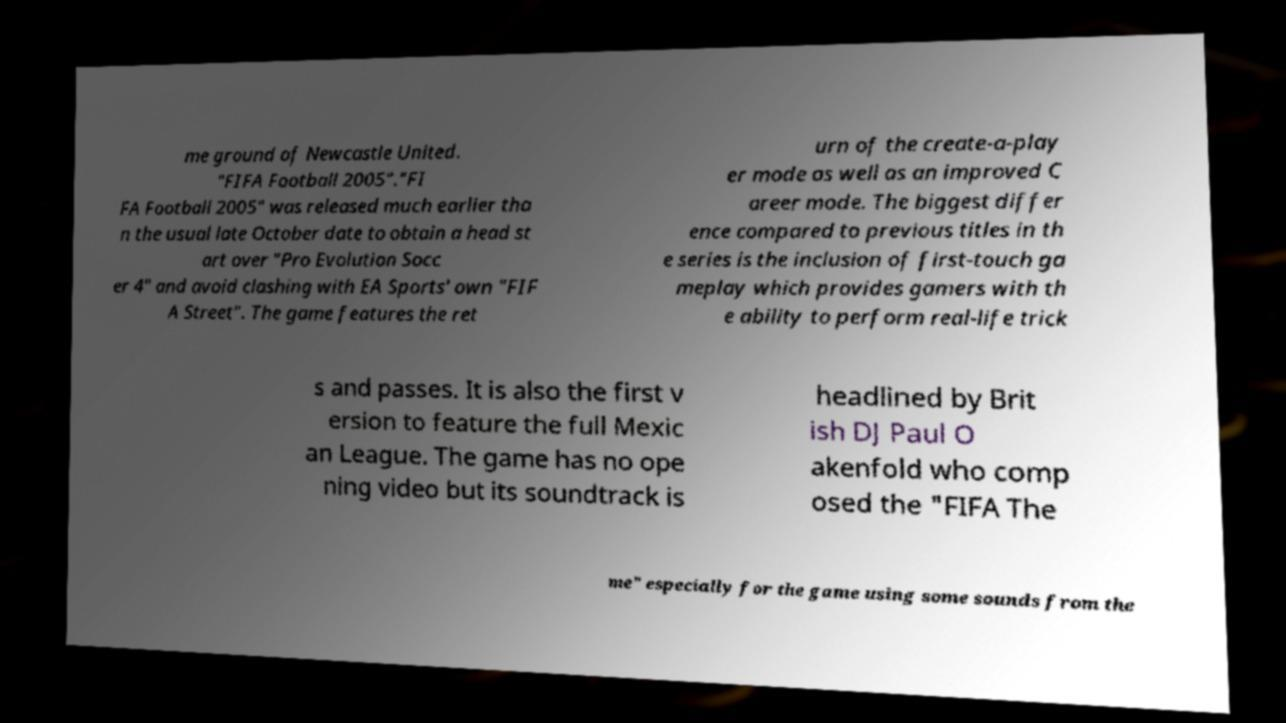Please read and relay the text visible in this image. What does it say? me ground of Newcastle United. "FIFA Football 2005"."FI FA Football 2005" was released much earlier tha n the usual late October date to obtain a head st art over "Pro Evolution Socc er 4" and avoid clashing with EA Sports' own "FIF A Street". The game features the ret urn of the create-a-play er mode as well as an improved C areer mode. The biggest differ ence compared to previous titles in th e series is the inclusion of first-touch ga meplay which provides gamers with th e ability to perform real-life trick s and passes. It is also the first v ersion to feature the full Mexic an League. The game has no ope ning video but its soundtrack is headlined by Brit ish DJ Paul O akenfold who comp osed the "FIFA The me" especially for the game using some sounds from the 